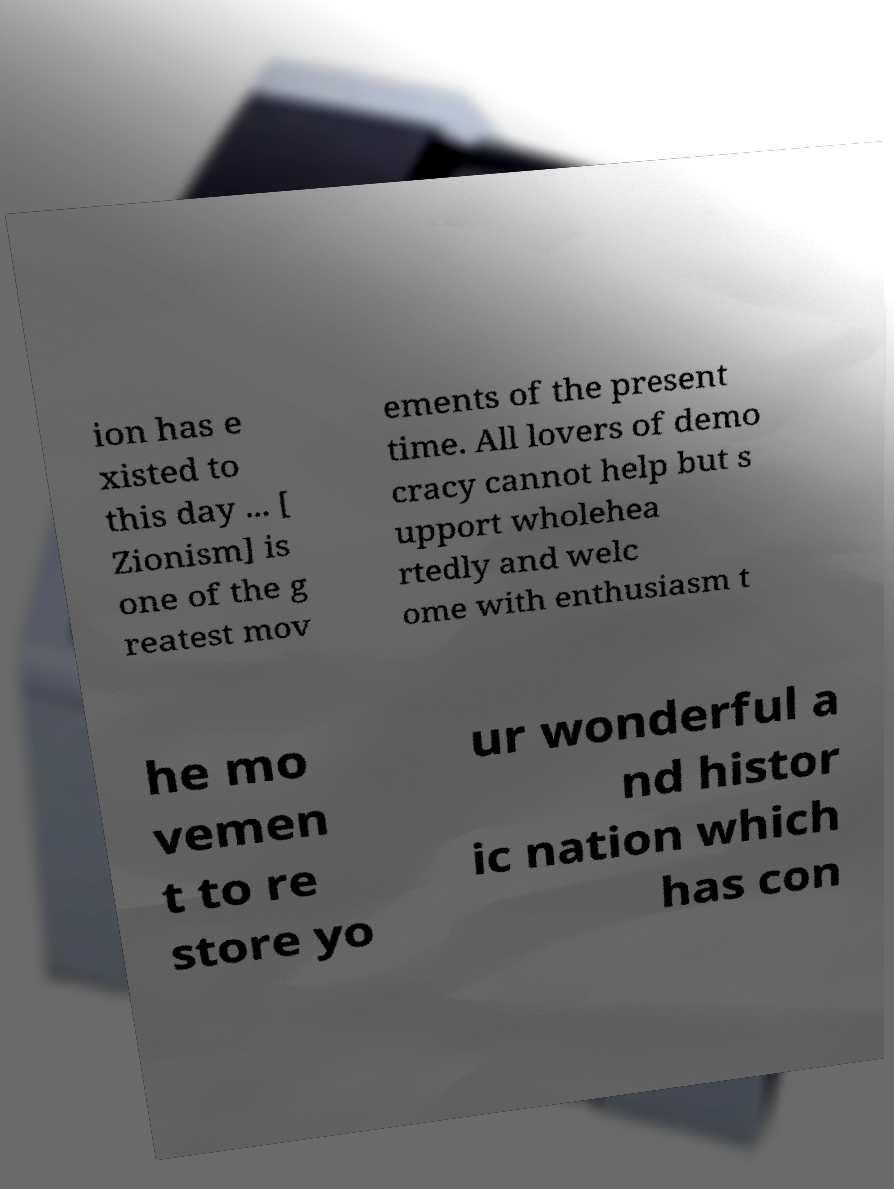Please read and relay the text visible in this image. What does it say? ion has e xisted to this day ... [ Zionism] is one of the g reatest mov ements of the present time. All lovers of demo cracy cannot help but s upport wholehea rtedly and welc ome with enthusiasm t he mo vemen t to re store yo ur wonderful a nd histor ic nation which has con 